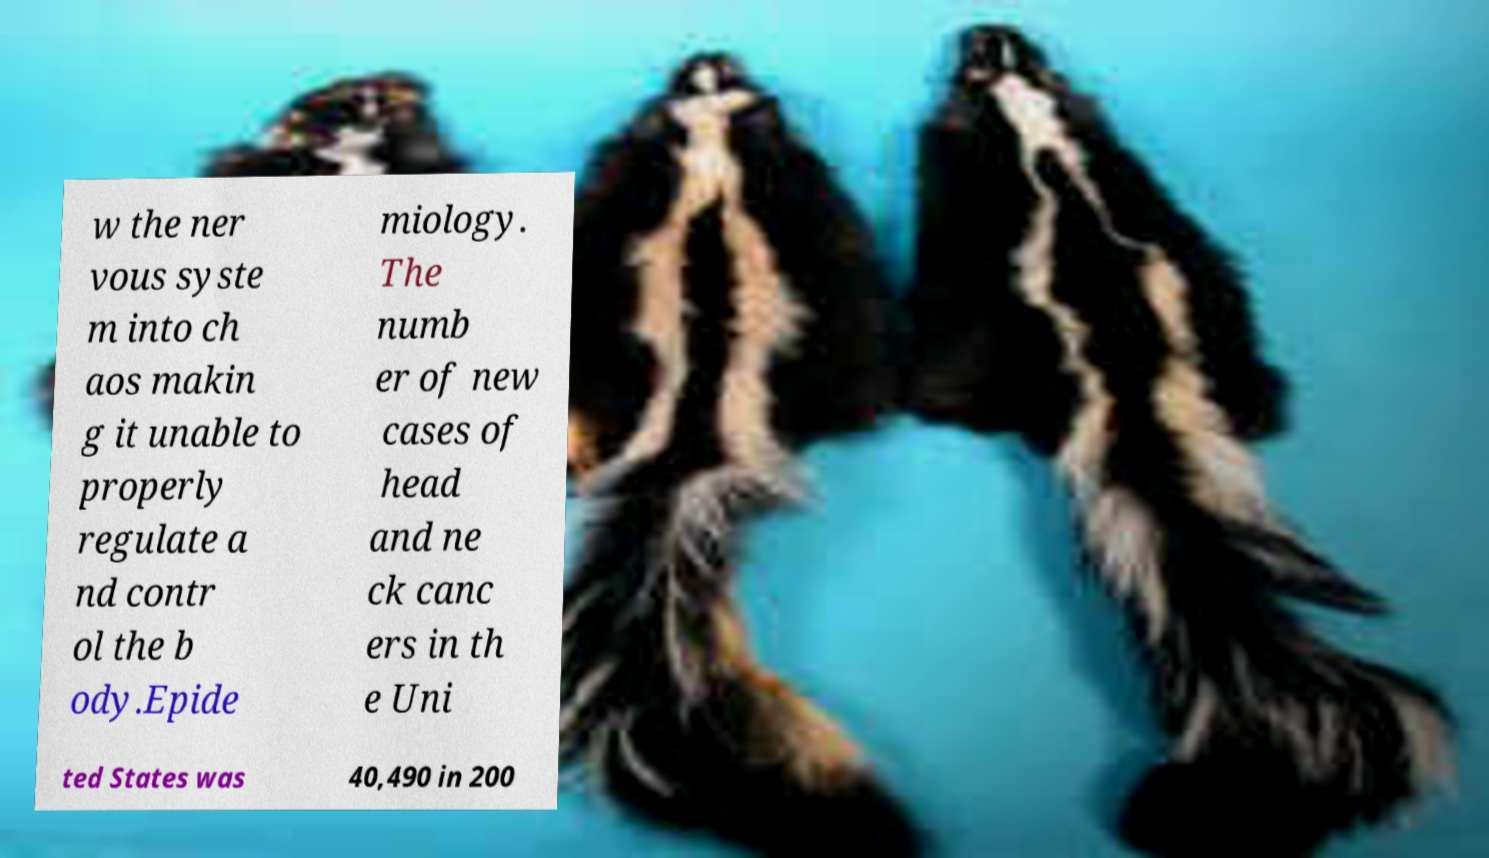I need the written content from this picture converted into text. Can you do that? w the ner vous syste m into ch aos makin g it unable to properly regulate a nd contr ol the b ody.Epide miology. The numb er of new cases of head and ne ck canc ers in th e Uni ted States was 40,490 in 200 